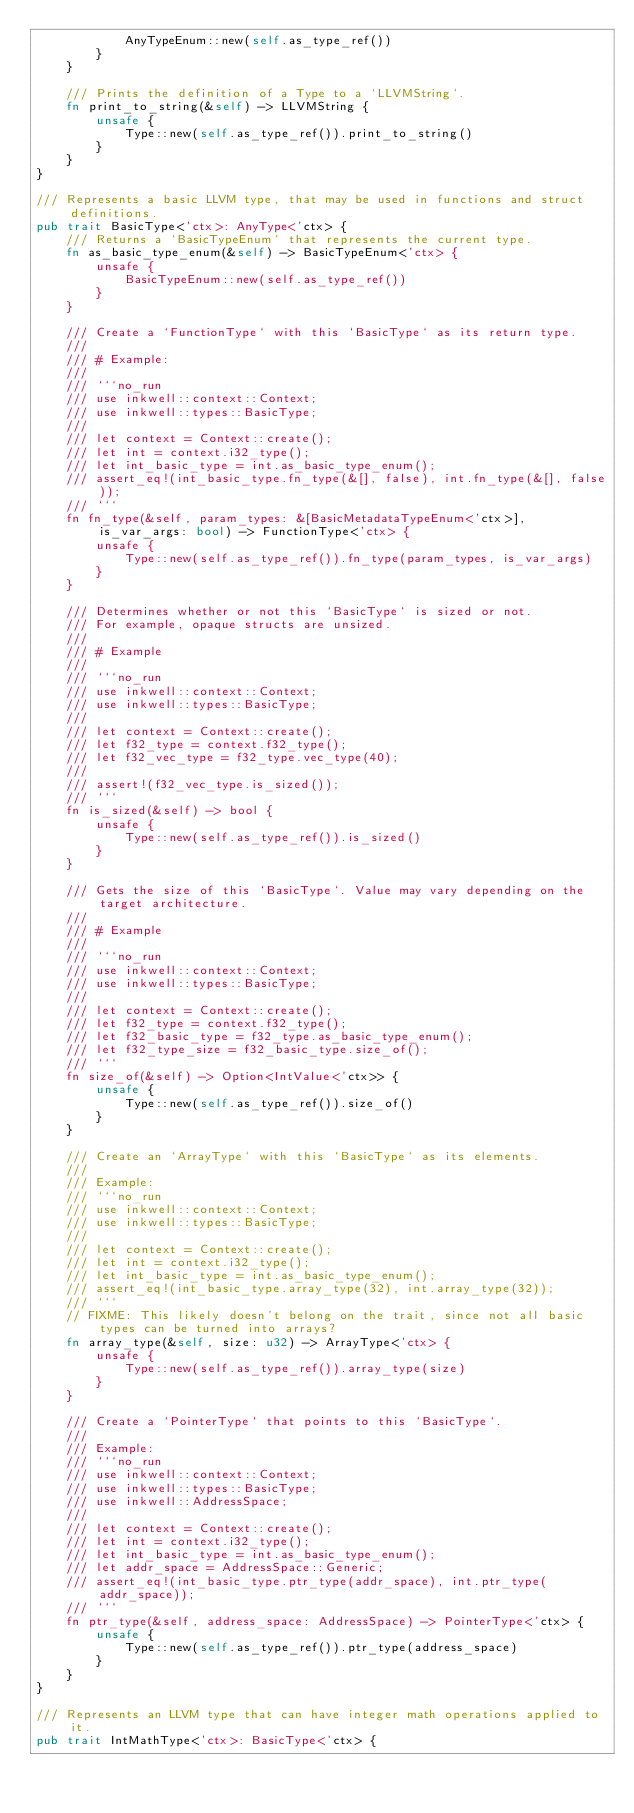Convert code to text. <code><loc_0><loc_0><loc_500><loc_500><_Rust_>            AnyTypeEnum::new(self.as_type_ref())
        }
    }

    /// Prints the definition of a Type to a `LLVMString`.
    fn print_to_string(&self) -> LLVMString {
        unsafe {
            Type::new(self.as_type_ref()).print_to_string()
        }
    }
}

/// Represents a basic LLVM type, that may be used in functions and struct definitions.
pub trait BasicType<'ctx>: AnyType<'ctx> {
    /// Returns a `BasicTypeEnum` that represents the current type.
    fn as_basic_type_enum(&self) -> BasicTypeEnum<'ctx> {
        unsafe {
            BasicTypeEnum::new(self.as_type_ref())
        }
    }

    /// Create a `FunctionType` with this `BasicType` as its return type.
    ///
    /// # Example:
    ///
    /// ```no_run
    /// use inkwell::context::Context;
    /// use inkwell::types::BasicType;
    ///
    /// let context = Context::create();
    /// let int = context.i32_type();
    /// let int_basic_type = int.as_basic_type_enum();
    /// assert_eq!(int_basic_type.fn_type(&[], false), int.fn_type(&[], false));
    /// ```
    fn fn_type(&self, param_types: &[BasicMetadataTypeEnum<'ctx>], is_var_args: bool) -> FunctionType<'ctx> {
        unsafe {
            Type::new(self.as_type_ref()).fn_type(param_types, is_var_args)
        }
    }

    /// Determines whether or not this `BasicType` is sized or not.
    /// For example, opaque structs are unsized.
    ///
    /// # Example
    ///
    /// ```no_run
    /// use inkwell::context::Context;
    /// use inkwell::types::BasicType;
    ///
    /// let context = Context::create();
    /// let f32_type = context.f32_type();
    /// let f32_vec_type = f32_type.vec_type(40);
    ///
    /// assert!(f32_vec_type.is_sized());
    /// ```
    fn is_sized(&self) -> bool {
        unsafe {
            Type::new(self.as_type_ref()).is_sized()
        }
    }

    /// Gets the size of this `BasicType`. Value may vary depending on the target architecture.
    ///
    /// # Example
    ///
    /// ```no_run
    /// use inkwell::context::Context;
    /// use inkwell::types::BasicType;
    ///
    /// let context = Context::create();
    /// let f32_type = context.f32_type();
    /// let f32_basic_type = f32_type.as_basic_type_enum();
    /// let f32_type_size = f32_basic_type.size_of();
    /// ```
    fn size_of(&self) -> Option<IntValue<'ctx>> {
        unsafe {
            Type::new(self.as_type_ref()).size_of()
        }
    }

    /// Create an `ArrayType` with this `BasicType` as its elements.
    ///
    /// Example:
    /// ```no_run
    /// use inkwell::context::Context;
    /// use inkwell::types::BasicType;
    ///
    /// let context = Context::create();
    /// let int = context.i32_type();
    /// let int_basic_type = int.as_basic_type_enum();
    /// assert_eq!(int_basic_type.array_type(32), int.array_type(32));
    /// ```
    // FIXME: This likely doesn't belong on the trait, since not all basic types can be turned into arrays?
    fn array_type(&self, size: u32) -> ArrayType<'ctx> {
        unsafe {
            Type::new(self.as_type_ref()).array_type(size)
        }
    }

    /// Create a `PointerType` that points to this `BasicType`.
    ///
    /// Example:
    /// ```no_run
    /// use inkwell::context::Context;
    /// use inkwell::types::BasicType;
    /// use inkwell::AddressSpace;
    ///
    /// let context = Context::create();
    /// let int = context.i32_type();
    /// let int_basic_type = int.as_basic_type_enum();
    /// let addr_space = AddressSpace::Generic;
    /// assert_eq!(int_basic_type.ptr_type(addr_space), int.ptr_type(addr_space));
    /// ```
    fn ptr_type(&self, address_space: AddressSpace) -> PointerType<'ctx> {
        unsafe {
            Type::new(self.as_type_ref()).ptr_type(address_space)
        }
    }
}

/// Represents an LLVM type that can have integer math operations applied to it.
pub trait IntMathType<'ctx>: BasicType<'ctx> {</code> 